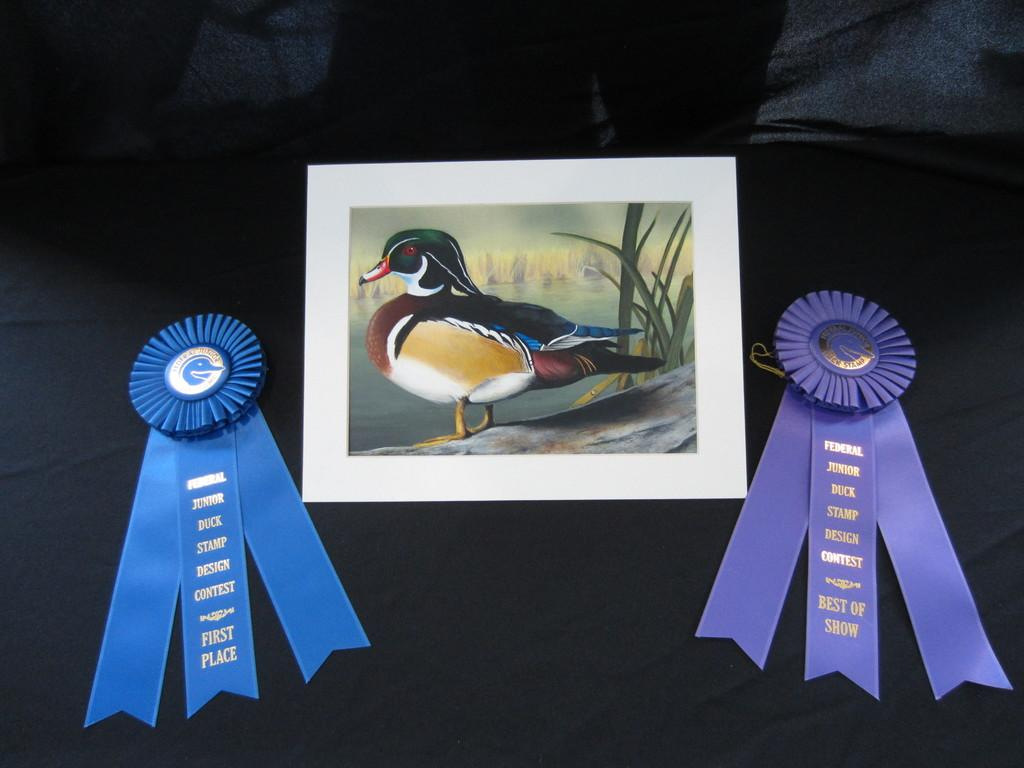What objects are in the foreground of the image? There are two ribbon batches and a frame in the foreground of the image. What is the color of the surface beneath the objects in the foreground? The surface beneath the ribbon batches and frame is black. What type of butter is being used to hold the ribbon batches together in the image? There is no butter present in the image; the ribbon batches are not held together by any substance. 